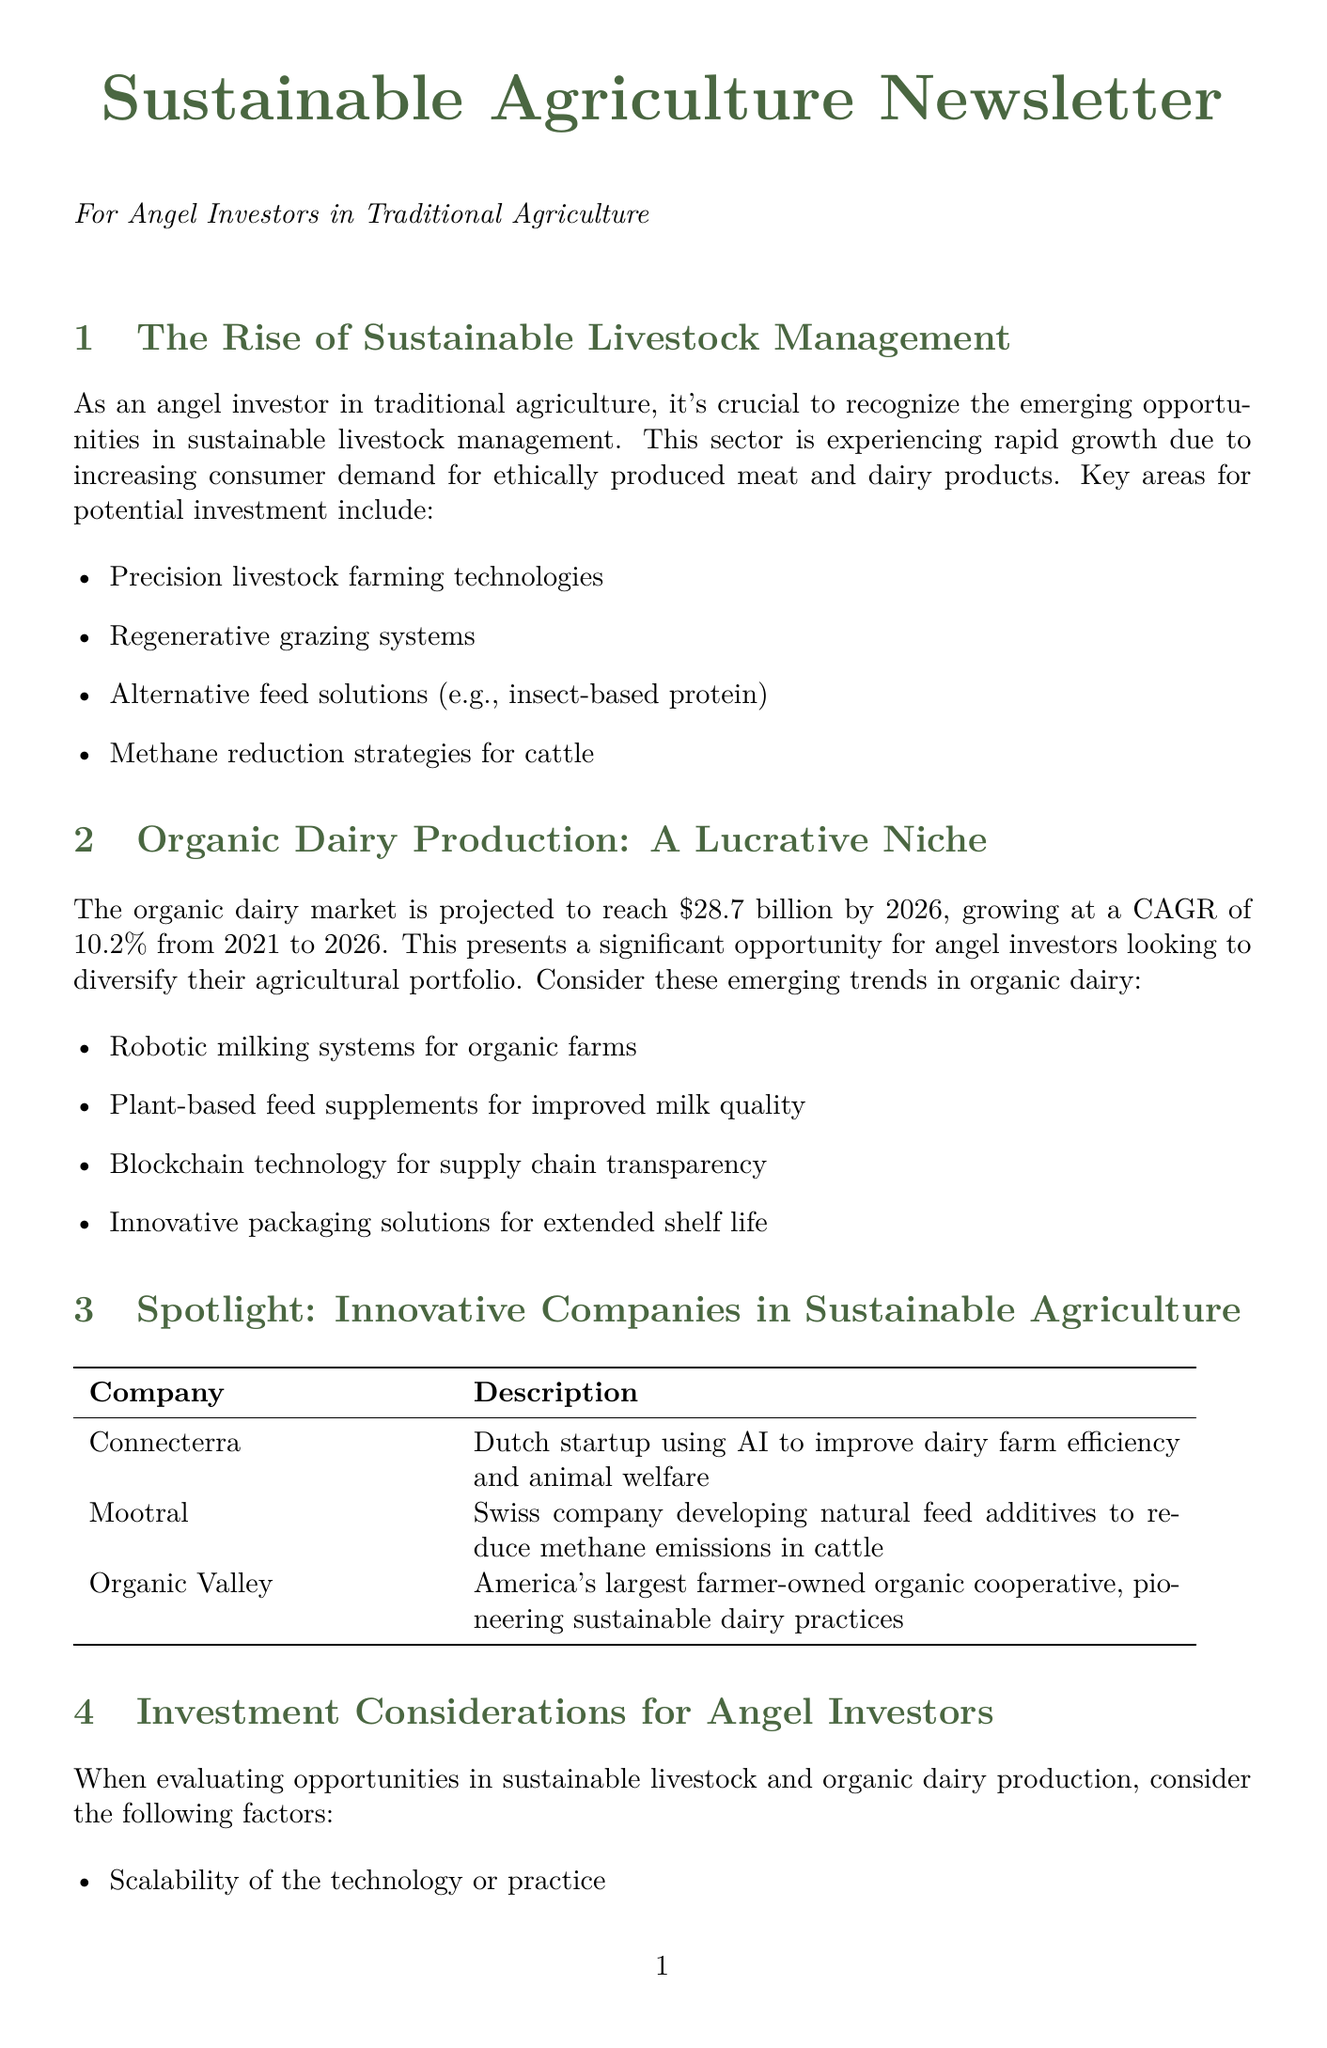What is the projected organic dairy market size by 2026? The projected organic dairy market size by 2026 is highlighted in the document, which states it will reach $28.7 billion.
Answer: $28.7 billion Which company focuses on using AI for dairy farm efficiency? Connecterra is noted in the document as a company focusing on using AI to improve dairy farm efficiency and animal welfare.
Answer: Connecterra What technology is mentioned for improving milk quality? The document mentions plant-based feed supplements as a technology to improve milk quality in organic dairy production.
Answer: Plant-based feed supplements What are the dates for the Organic Dairy Conference? The document lists the dates for the Organic Dairy Conference as March 14-15, 2024.
Answer: March 14-15, 2024 Name one methane reduction strategy for cattle. One of the methane reduction strategies for cattle listed in the document is natural feed additives developed by Mootral.
Answer: Natural feed additives What key factor should angel investors evaluate regarding scalability? The document emphasizes 'scalability of the technology or practice' as a significant factor for angel investors to consider.
Answer: Scalability of the technology or practice How much is the CAGR for the organic dairy market growth from 2021 to 2026? The document specifies that the CAGR for the organic dairy market from 2021 to 2026 is 10.2 percent.
Answer: 10.2 percent What is highlighted as an innovative packaging solution for organic dairy? The document highlights innovative packaging solutions for extended shelf life as an emerging trend in organic dairy.
Answer: Innovative packaging solutions for extended shelf life 